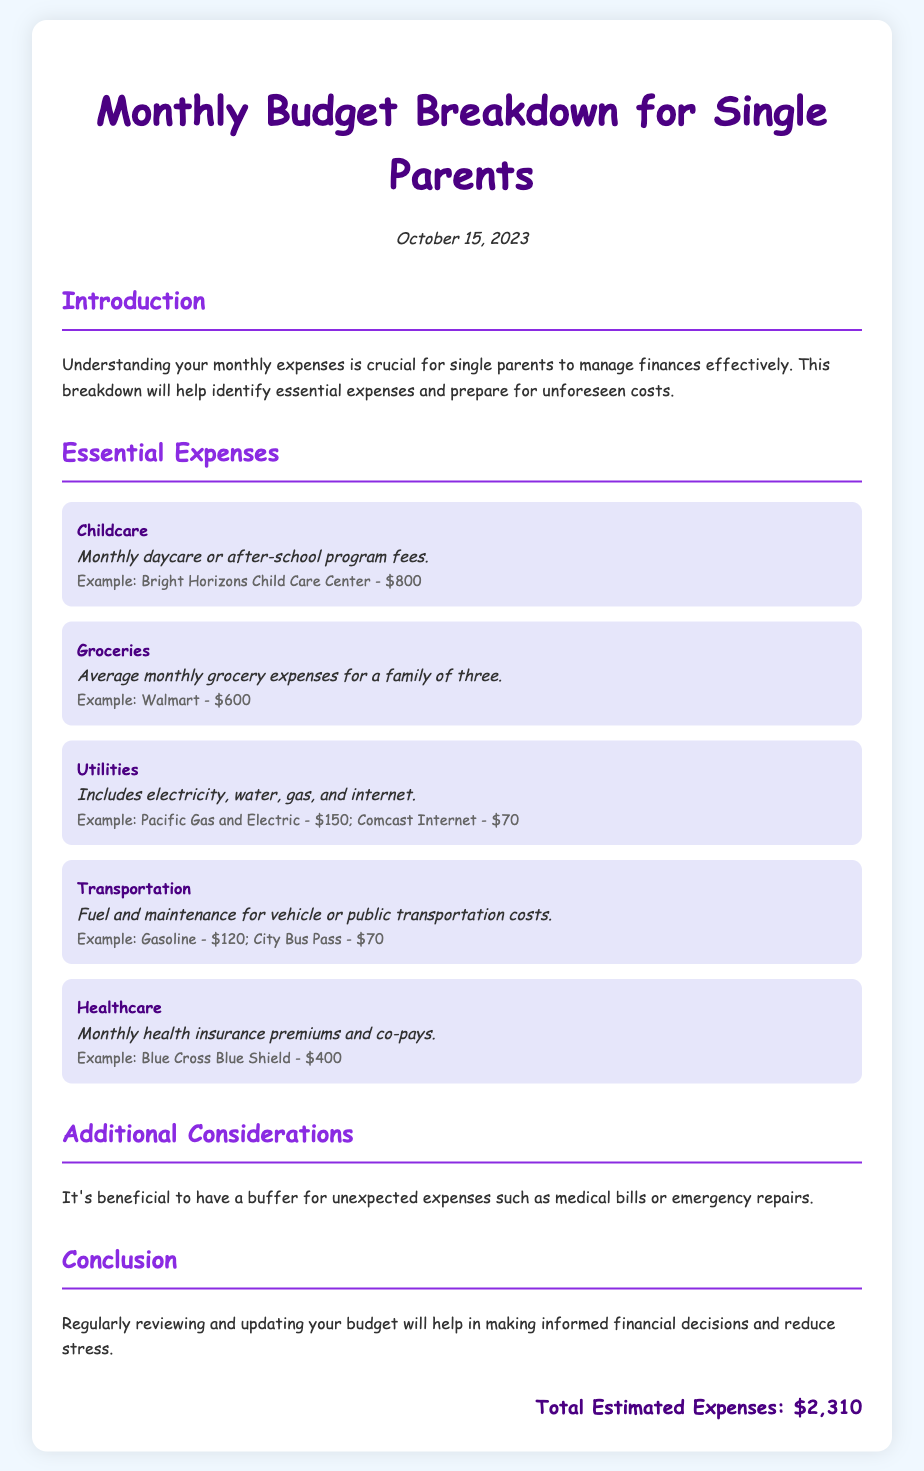What is the total estimated expenses? The total estimated expenses are calculated by summing all the essential expenses listed in the document.
Answer: $2,310 What is the monthly daycare fee mentioned? The document specifies a monthly daycare or after-school program fee as an example.
Answer: $800 How much is allocated for grocery expenses? The average monthly grocery expenses for a family of three are provided in the document.
Answer: $600 Which utility expenses are included? The document lists the types of utility expenses covered, such as electricity, water, gas, and internet.
Answer: Electricity, water, gas, internet What is the healthcare premium amount? The document mentions a specific example for monthly health insurance premiums.
Answer: $400 What additional consideration is mentioned for budgeting? The document provides a suggestion for managing unexpected financial situations when budgeting.
Answer: Buffer for unexpected expenses How much is the transportation budget? The document details transportation costs, including fuel and maintenance for a vehicle.
Answer: $190 What is the date of the budget breakdown? The document indicates the date the budget breakdown was prepared.
Answer: October 15, 2023 What is the introduction about? The introduction provides insight into the importance of understanding monthly expenses for effective financial management.
Answer: Importance of understanding monthly expenses 